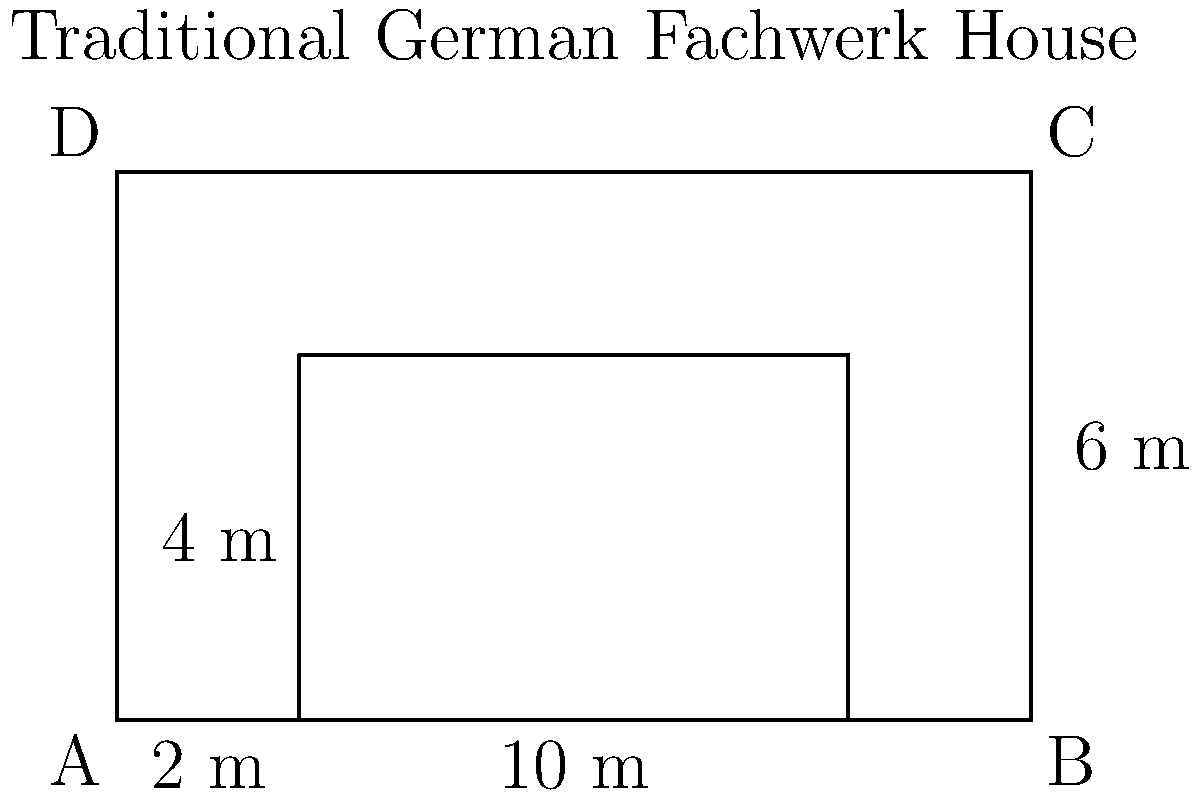A traditional German Fachwerk house has a rectangular shape with an inner courtyard, as shown in the diagram. The outer dimensions of the house are 10 meters by 6 meters, and the inner courtyard is 6 meters by 4 meters. Calculate the perimeter of the house, including both the outer and inner perimeters. To calculate the total perimeter, we need to add the outer and inner perimeters:

1. Outer perimeter:
   - Length of the house: 10 m
   - Width of the house: 6 m
   - Outer perimeter = $2 \times (10 \text{ m} + 6 \text{ m}) = 2 \times 16 \text{ m} = 32 \text{ m}$

2. Inner perimeter (courtyard):
   - Length of the courtyard: 6 m
   - Width of the courtyard: 4 m
   - Inner perimeter = $2 \times (6 \text{ m} + 4 \text{ m}) = 2 \times 10 \text{ m} = 20 \text{ m}$

3. Total perimeter:
   - Total perimeter = Outer perimeter + Inner perimeter
   - Total perimeter = $32 \text{ m} + 20 \text{ m} = 52 \text{ m}$

Therefore, the total perimeter of the Fachwerk house, including both the outer and inner perimeters, is 52 meters.
Answer: 52 m 